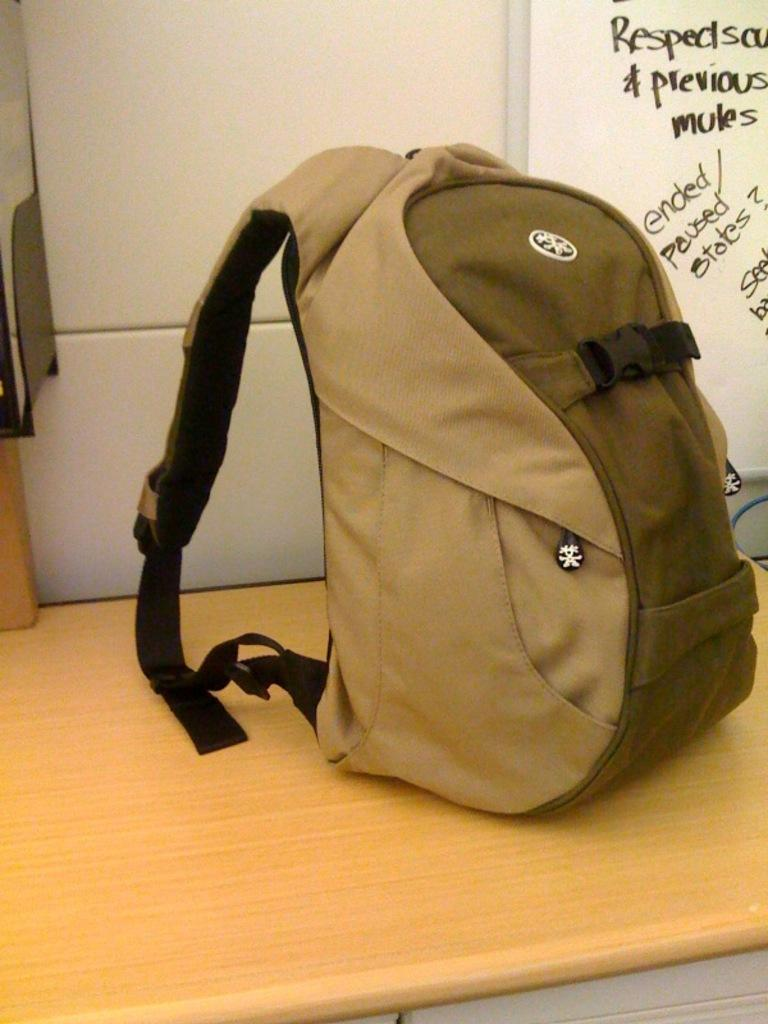What object is placed on the table in the image? There is a bag on the table in the image. What can be seen on the wall in the image? There is a note on the wall in the image. How many waves can be seen crashing on the shore in the image? There are no waves present in the image; it only features a bag on the table and a note on the wall. How many girls are visible in the image? There are no girls present in the image; it only features a bag on the table and a note on the wall. 